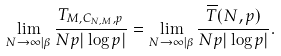Convert formula to latex. <formula><loc_0><loc_0><loc_500><loc_500>\lim _ { N \to \infty | \beta } \frac { T _ { M , C _ { N , M } , p } } { N p | \log p | } = \lim _ { N \to \infty | \beta } \frac { \overline { T } ( N , p ) } { N p | \log p | } .</formula> 